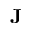Convert formula to latex. <formula><loc_0><loc_0><loc_500><loc_500>J</formula> 